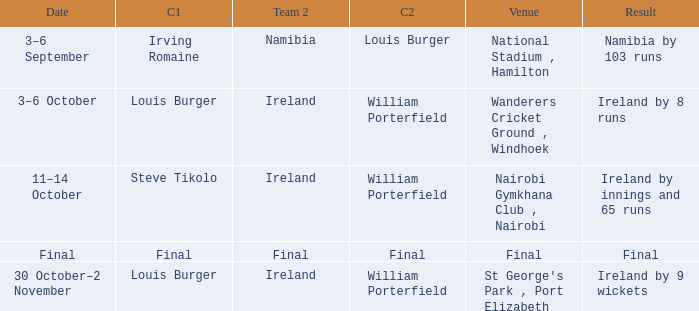Which Result has a Captain 1 of louis burger, and a Date of 30 october–2 november? Ireland by 9 wickets. 